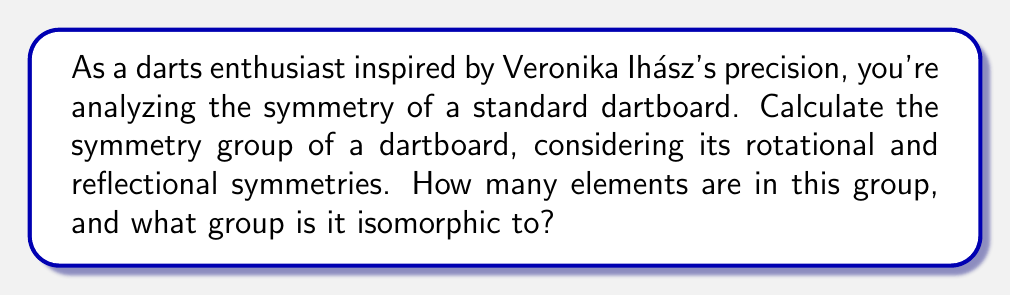Solve this math problem. Let's approach this step-by-step:

1) First, let's consider the structure of a standard dartboard:
   - It has 20 numbered sections arranged in a circular pattern.
   - Each section is divided into single, double, and triple scoring areas.
   - There's a central bullseye (usually red) and an outer bullseye (usually green).

2) Rotational symmetries:
   - The dartboard can be rotated by 18° (360°/20) and still look the same.
   - This gives us 20 rotational symmetries (including the identity rotation).

3) Reflectional symmetries:
   - There are 20 lines of reflection, each passing through the center and between two adjacent numbered sections.

4) Total number of symmetries:
   - Total symmetries = Rotational symmetries + Reflectional symmetries
   - Total = 20 + 20 = 40

5) Group structure:
   - This group of symmetries is known as the dihedral group of order 40, denoted as $D_{40}$ or $D_{20}$.
   - It's generated by two elements: $r$ (rotation by 18°) and $s$ (reflection).
   - The group has the following properties:
     $$r^{20} = e$$ (where $e$ is the identity element)
     $$s^2 = e$$
     $$srs = r^{-1}$$

6) Group order:
   - The order of the group is 40, as we calculated earlier.

7) Isomorphism:
   - This group is isomorphic to the dihedral group $D_{40}$ (or $D_{20}$, depending on notation).

Therefore, the symmetry group of a dartboard has 40 elements and is isomorphic to the dihedral group $D_{40}$ (or $D_{20}$).
Answer: $D_{40}$ (or $D_{20}$), order 40 